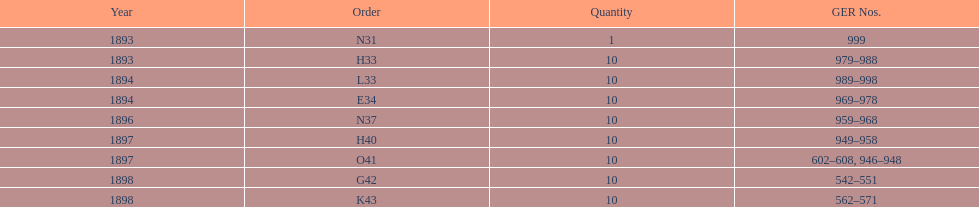Were there more n31 or e34 ordered? E34. 